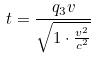<formula> <loc_0><loc_0><loc_500><loc_500>t = \frac { q _ { 3 } v } { \sqrt { 1 \cdot \frac { v ^ { 2 } } { c ^ { 2 } } } }</formula> 